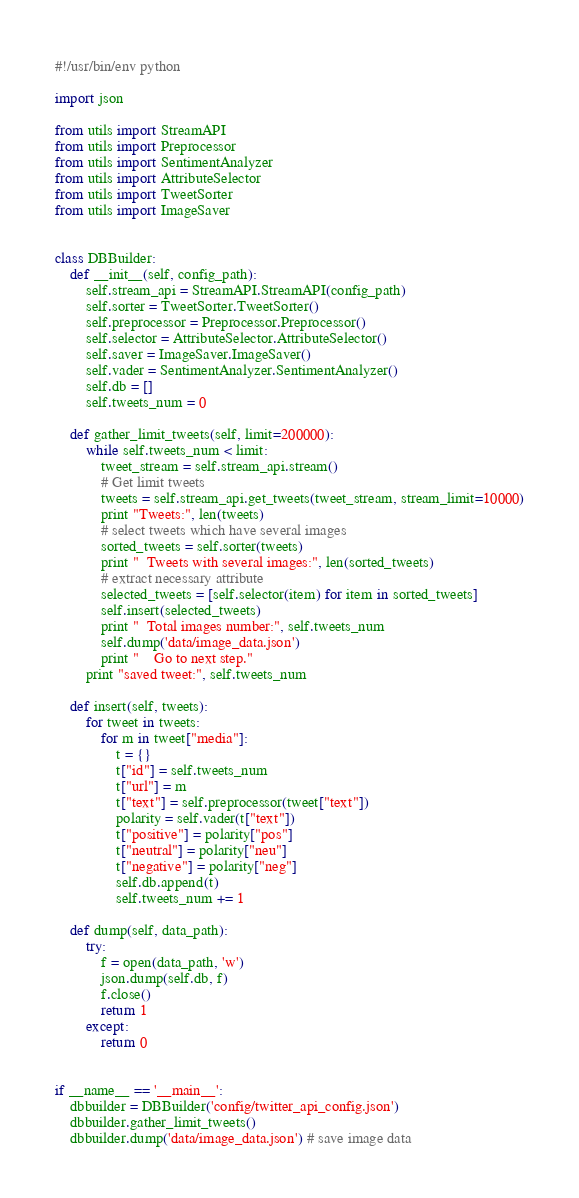Convert code to text. <code><loc_0><loc_0><loc_500><loc_500><_Python_>#!/usr/bin/env python

import json

from utils import StreamAPI
from utils import Preprocessor
from utils import SentimentAnalyzer
from utils import AttributeSelector
from utils import TweetSorter
from utils import ImageSaver


class DBBuilder:
    def __init__(self, config_path):
        self.stream_api = StreamAPI.StreamAPI(config_path)
        self.sorter = TweetSorter.TweetSorter()
        self.preprocessor = Preprocessor.Preprocessor()
        self.selector = AttributeSelector.AttributeSelector()
        self.saver = ImageSaver.ImageSaver()
        self.vader = SentimentAnalyzer.SentimentAnalyzer()
        self.db = []
        self.tweets_num = 0

    def gather_limit_tweets(self, limit=200000):
        while self.tweets_num < limit:
            tweet_stream = self.stream_api.stream()
            # Get limit tweets
            tweets = self.stream_api.get_tweets(tweet_stream, stream_limit=10000)
            print "Tweets:", len(tweets)
            # select tweets which have several images
            sorted_tweets = self.sorter(tweets)
            print "  Tweets with several images:", len(sorted_tweets)
            # extract necessary attribute
            selected_tweets = [self.selector(item) for item in sorted_tweets]
            self.insert(selected_tweets)
            print "  Total images number:", self.tweets_num
            self.dump('data/image_data.json')
            print "    Go to next step."
        print "saved tweet:", self.tweets_num

    def insert(self, tweets):
        for tweet in tweets:
            for m in tweet["media"]:
                t = {}
                t["id"] = self.tweets_num
                t["url"] = m
                t["text"] = self.preprocessor(tweet["text"])
                polarity = self.vader(t["text"])
                t["positive"] = polarity["pos"]
                t["neutral"] = polarity["neu"]
                t["negative"] = polarity["neg"]
                self.db.append(t)
                self.tweets_num += 1

    def dump(self, data_path):
        try:
            f = open(data_path, 'w')
            json.dump(self.db, f)
            f.close()
            return 1
        except:
            return 0


if __name__ == '__main__':
    dbbuilder = DBBuilder('config/twitter_api_config.json')
    dbbuilder.gather_limit_tweets()
    dbbuilder.dump('data/image_data.json') # save image data
</code> 